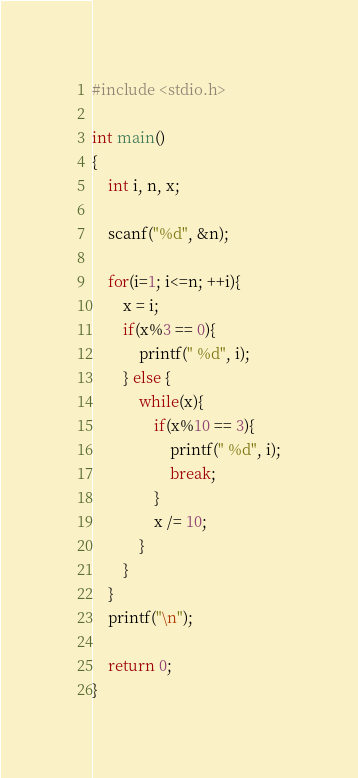<code> <loc_0><loc_0><loc_500><loc_500><_C_>#include <stdio.h>

int main()
{
    int i, n, x;
    
    scanf("%d", &n);
    
    for(i=1; i<=n; ++i){
        x = i;
        if(x%3 == 0){
            printf(" %d", i);
        } else {
            while(x){
                if(x%10 == 3){
                    printf(" %d", i);
                    break;
                }
                x /= 10;
            }
        }
    }
    printf("\n");
    
    return 0;
}</code> 